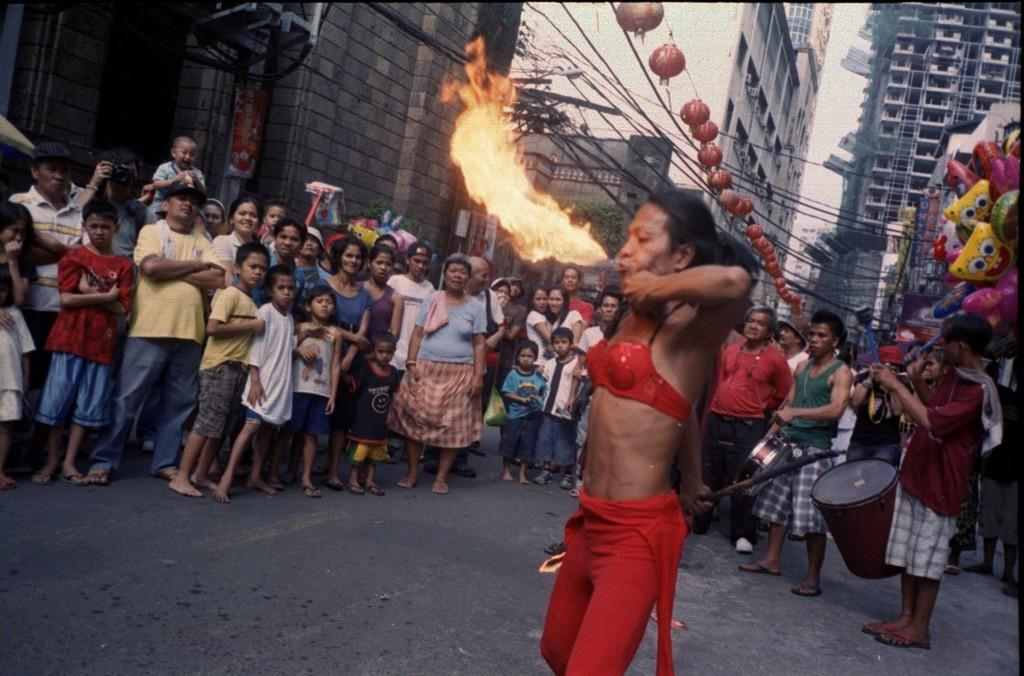Who is the main subject in the image? There is a woman in the image. What is the woman doing in the image? The woman is blowing fire. What can be seen in the background of the image? There is a group of people and buildings visible in the background of the image. What type of owl can be seen in the image? There is no owl present in the image. Is the woman in the image bleeding? There is no indication of blood or injury in the image. 